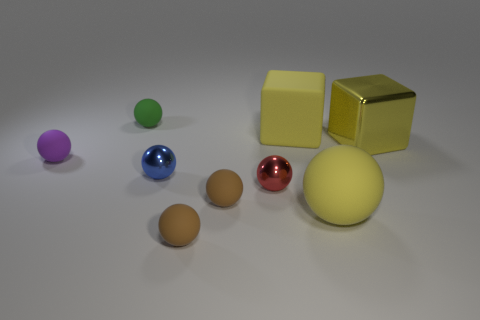Subtract all small matte balls. How many balls are left? 3 Subtract all blocks. How many objects are left? 7 Add 1 small cyan things. How many objects exist? 10 Subtract all green balls. How many balls are left? 6 Subtract all cyan balls. How many brown blocks are left? 0 Subtract all yellow shiny things. Subtract all cyan balls. How many objects are left? 8 Add 2 small balls. How many small balls are left? 8 Add 2 yellow metal things. How many yellow metal things exist? 3 Subtract 0 cyan spheres. How many objects are left? 9 Subtract 6 balls. How many balls are left? 1 